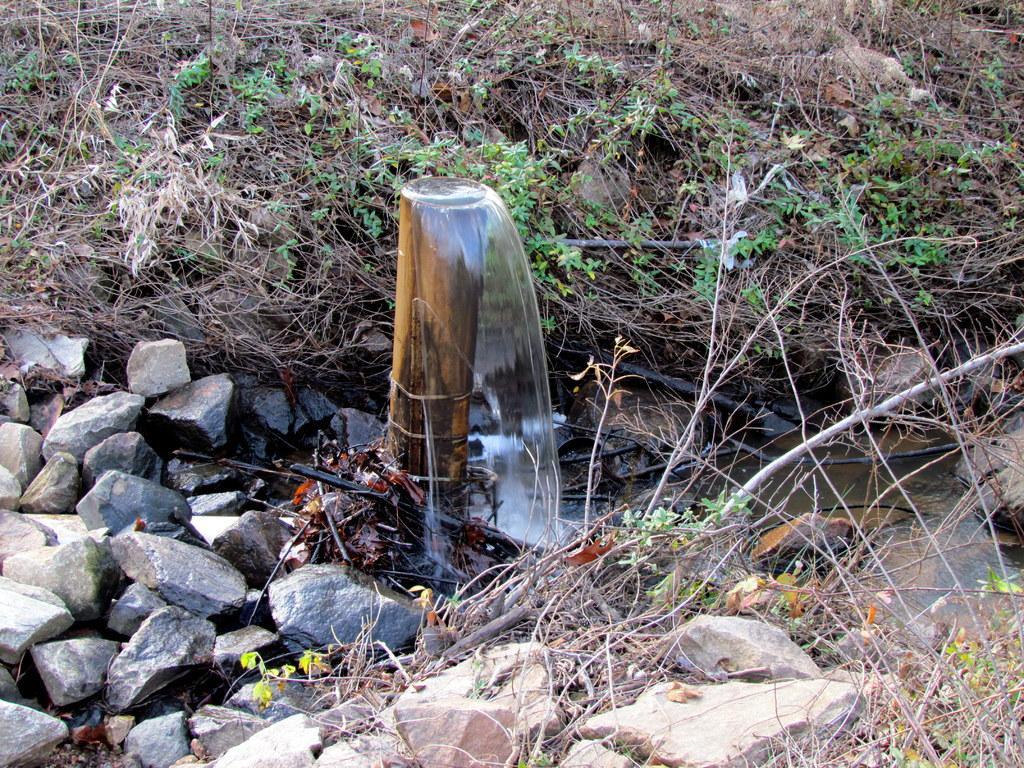Please provide a concise description of this image. In the center of the image we can see a fountain. At the bottom there are rocks and we can see twigs. In the background there are plants. 